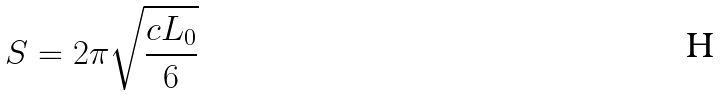<formula> <loc_0><loc_0><loc_500><loc_500>S = 2 \pi \sqrt { \frac { c L _ { 0 } } { 6 } }</formula> 